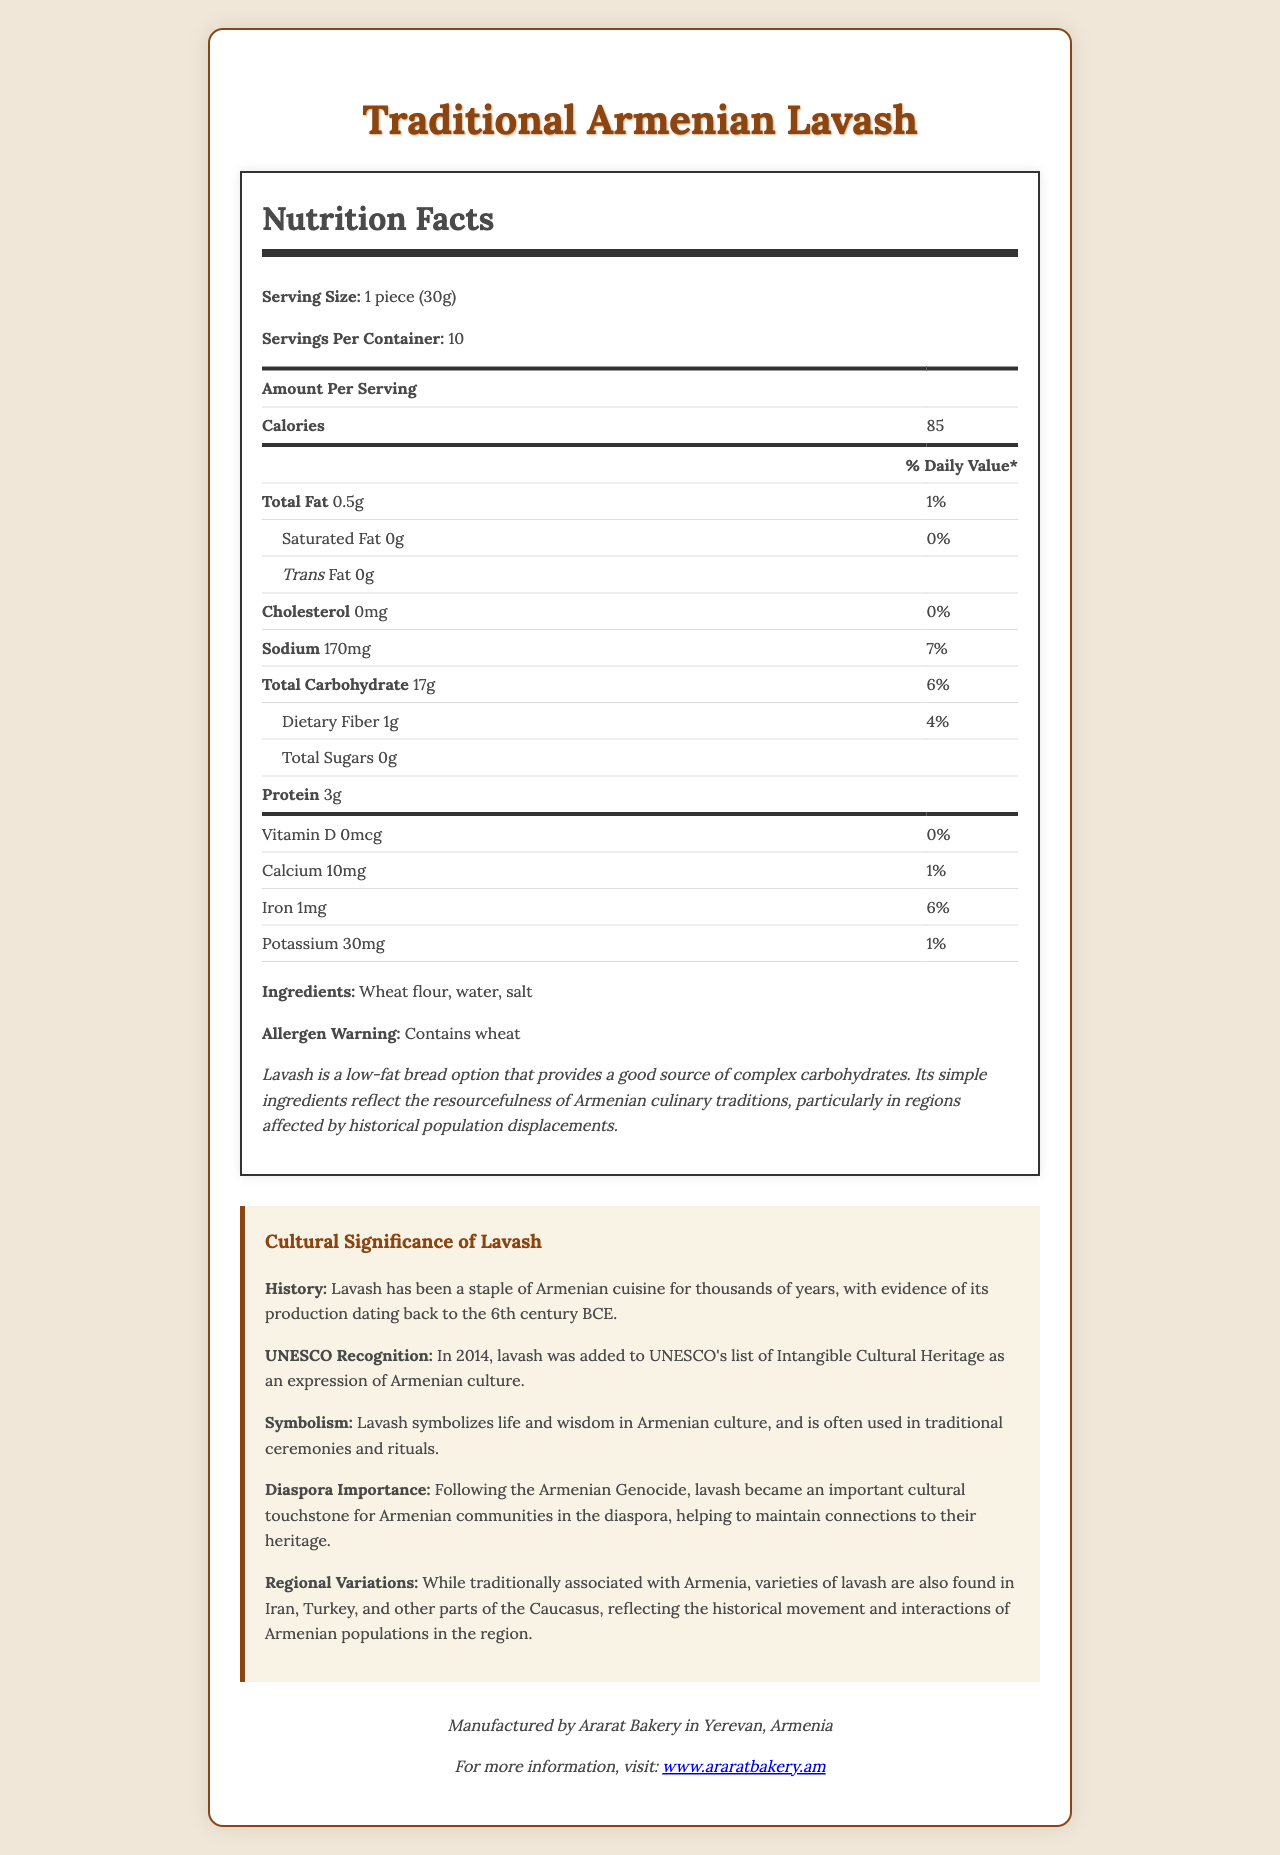What is the serving size of Traditional Armenian Lavash? The serving size is clearly listed under the "Nutrition Facts" section as 1 piece (30g).
Answer: 1 piece (30g) How many calories are there per serving of the lavash? The calorie content per serving is listed in the "Amount Per Serving" section as 85 calories.
Answer: 85 What percentage of the daily value of sodium does one serving of lavash provide? The document states that one serving of lavash contains 170mg of sodium, which is 7% of the daily value.
Answer: 7% What are the main ingredients in Traditional Armenian Lavash? The ingredients are listed at the bottom of the nutrition label as wheat flour, water, salt.
Answer: Wheat flour, water, salt How much protein does one serving of lavash contain? The amount of protein per serving is mentioned in the nutrition label as 3g.
Answer: 3g Which nutrient is present in the highest daily value percentage in the lavash? A. Sodium B. Iron C. Total Carbohydrate D. Dietary Fiber Sodium has the highest daily value percentage at 7%, followed by iron at 6% and total carbohydrate at 6%.
Answer: A. Sodium Which of the following historical facts about lavash is NOT mentioned in the document? I. Lavash dates back to the 6th century BCE II. Lavash was added to UNESCO's list of Intangible Cultural Heritage III. Lavash is made with milk IV. Lavash symbolizes life and wisdom The document doesn't mention lavash being made with milk. The other facts are stated in the "Cultural Significance" section.
Answer: III Is lavash considered a high-fat bread? The document states that lavash contains 0.5g of total fat per serving, which is only 1% of the daily value, indicating that it is low in fat.
Answer: No Describe the main cultural and nutritional aspects of Traditional Armenian Lavash as presented in the document. The document details both the nutritional aspects, indicating lavash as a low-fat bread with good complex carbohydrate content, and cultural aspects, highlighting its historical significance, symbolic meaning, and importance to the Armenian diaspora.
Answer: Traditional Armenian Lavash is a staple Armenian bread with low fat and good carbohydrate content. It has been part of Armenian cuisine since the 6th century BCE and holds cultural significance as a symbol of life and wisdom, being recognized by UNESCO. What were the effects of lavash in the Armenian diaspora community? The document states that lavash became an important cultural touchstone for Armenian communities in the diaspora, helping to maintain connections to their heritage.
Answer: It helped maintain connections to their heritage What is the manufacturer location of Traditional Armenian Lavash? The manufacturer's location is listed at the bottom of the document as Yerevan, Armenia.
Answer: Yerevan, Armenia How much iron does one serving of lavash provide? The amount of iron per serving is listed as 1mg in the nutrition label.
Answer: 1mg Does Traditional Armenian Lavash contain any cholesterol? The document states that the lavash contains 0mg of cholesterol.
Answer: No Who is the manufacturer of Traditional Armenian Lavash? The manufacturer is listed as Ararat Bakery in the "Manufacturer Info" section.
Answer: Ararat Bakery Is dietary fiber content in lavash high enough to meet 10% of the daily value? The dietary fiber content in lavash is 1g per serving, which is 4% of the daily value, not meeting the 10% requirement.
Answer: No What other regions/countries have variations of lavash according to the document? The document mentions that varieties of lavash are also found in Iran, Turkey, and other parts of the Caucasus.
Answer: Iran, Turkey, parts of the Caucasus In what year was lavash added to UNESCO's list of Intangible Cultural Heritage? The document mentions that lavash was added to UNESCO's list of Intangible Cultural Heritage in 2014.
Answer: 2014 How does lavash symbolize life and wisdom in Armenian culture? The symbolism and its use in ceremonies are highlighted in the "Cultural Significance" section.
Answer: The document states that lavash symbolizes life and wisdom in Armenian culture, often used in traditional ceremonies and rituals. How much calcium is in one serving of lavash bread? The nutrition label lists 10mg of calcium per serving.
Answer: 10mg What is the website of the manufacturer Ararat Bakery? The manufacturer's website is listed in the "Manufacturer Info" section of the document.
Answer: www.araratbakery.am Was lavash influenced solely by Armenian culture? The document states that while lavash is traditionally associated with Armenia, varieties are also found in Iran, Turkey, and other parts of the Caucasus, showcasing cultural interactions.
Answer: No 